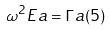Convert formula to latex. <formula><loc_0><loc_0><loc_500><loc_500>\omega ^ { 2 } E a = \Gamma a ( 5 )</formula> 